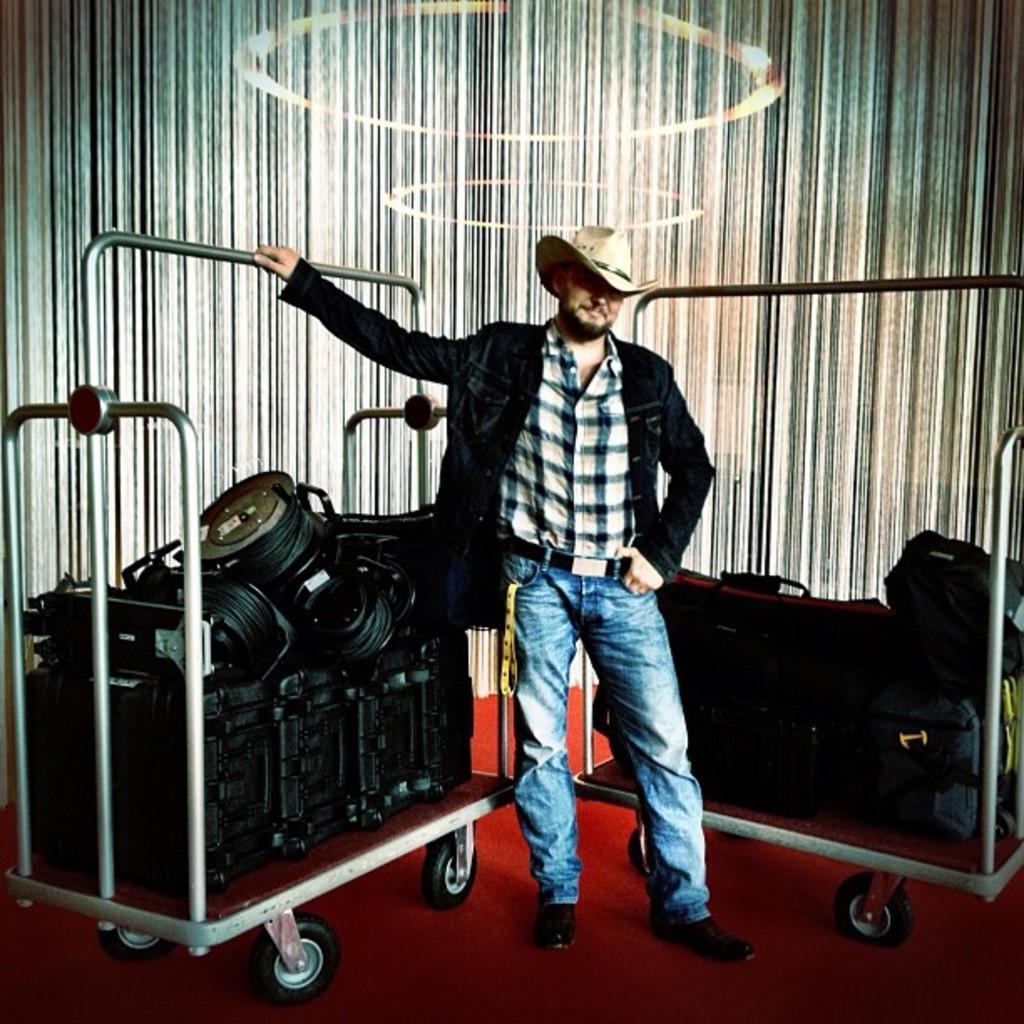How would you summarize this image in a sentence or two? In this image I can see a man is standing. I can see he is wearing blue jeans, black jacket, shirt, shoes and a hat. I can also see number of bags and few other stuffs on this trolleys. 